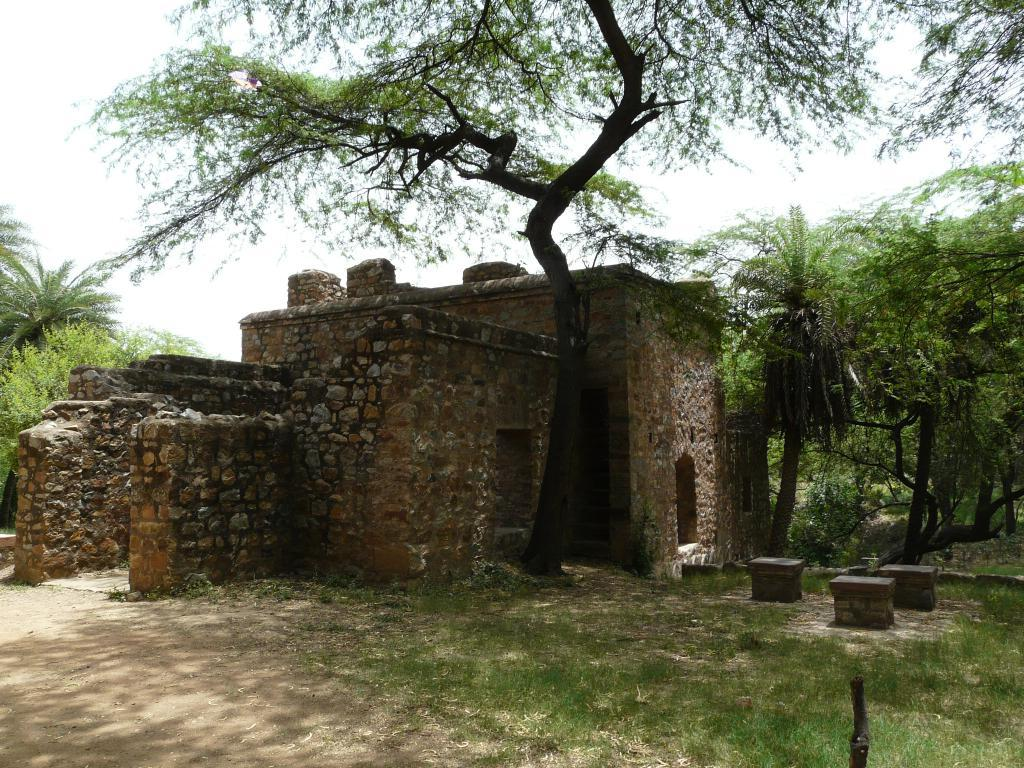What type of structure is visible in the image? There is a fort in the image. What type of vegetation can be seen in the image? There are trees, plants, and grass visible in the image. What is the surface at the bottom of the image? There is a walkway at the bottom of the image. What is the unspecified object in the image? Unfortunately, the facts provided do not specify the nature of the unspecified object. What can be seen in the background of the image? The sky is visible in the background of the image. How many sheep are grazing on the grass in the image? There are no sheep present in the image. What color is the rose on the walkway in the image? There is no rose present in the image. 